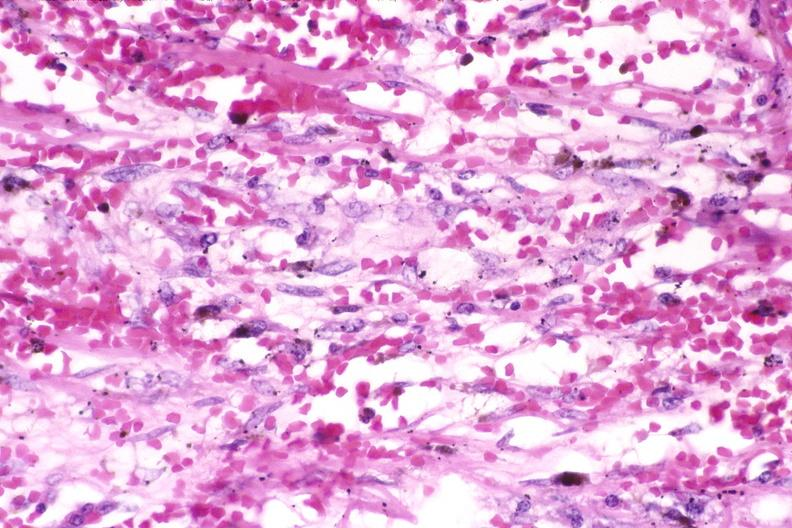what does this image show?
Answer the question using a single word or phrase. Skin 